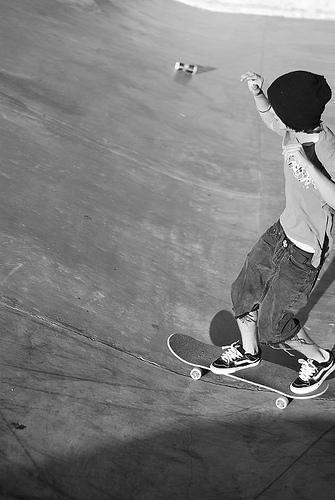How many skaters?
Give a very brief answer. 1. How many people are playing football?
Give a very brief answer. 0. 